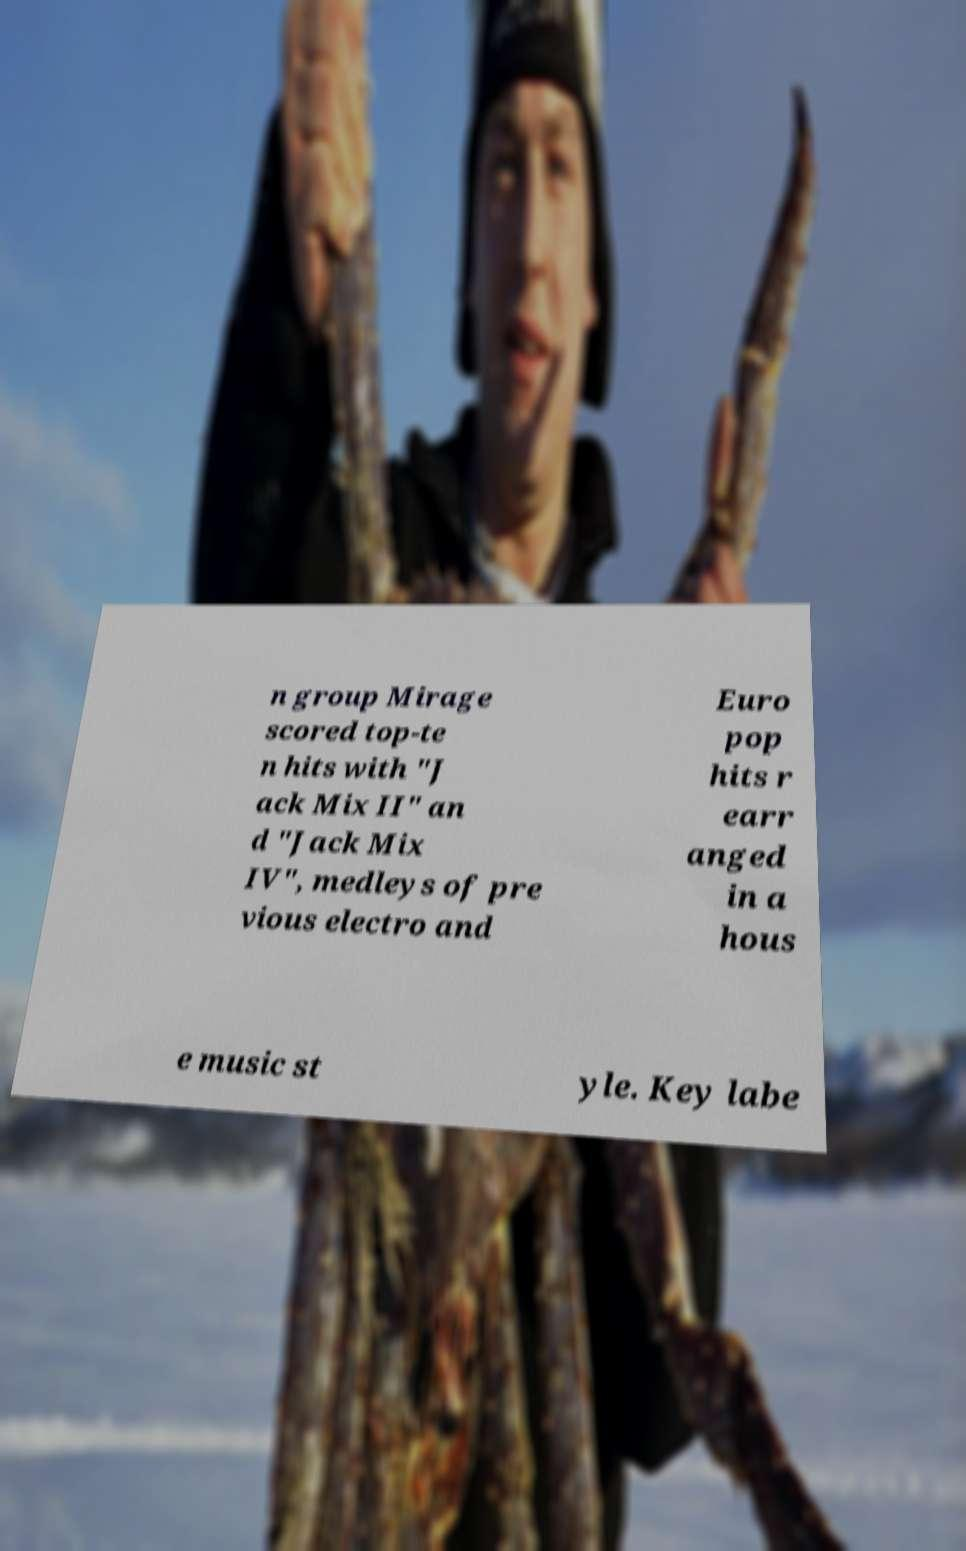Could you extract and type out the text from this image? n group Mirage scored top-te n hits with "J ack Mix II" an d "Jack Mix IV", medleys of pre vious electro and Euro pop hits r earr anged in a hous e music st yle. Key labe 